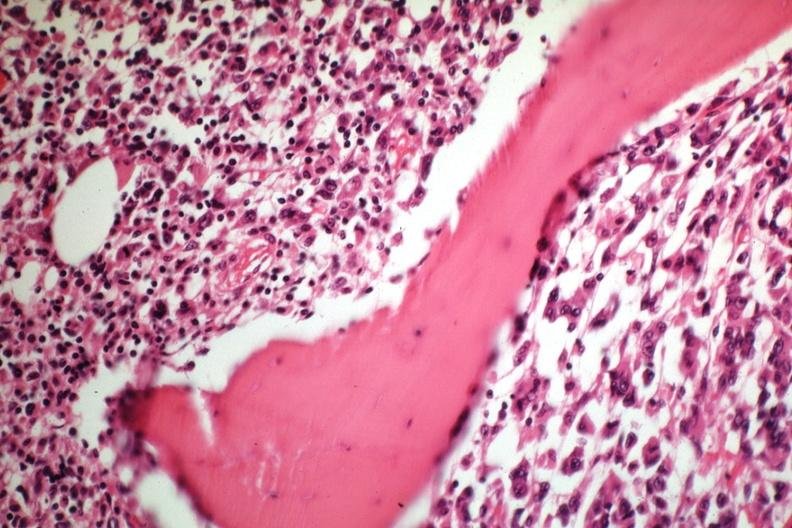s tumor well shown gross slide?
Answer the question using a single word or phrase. Yes 